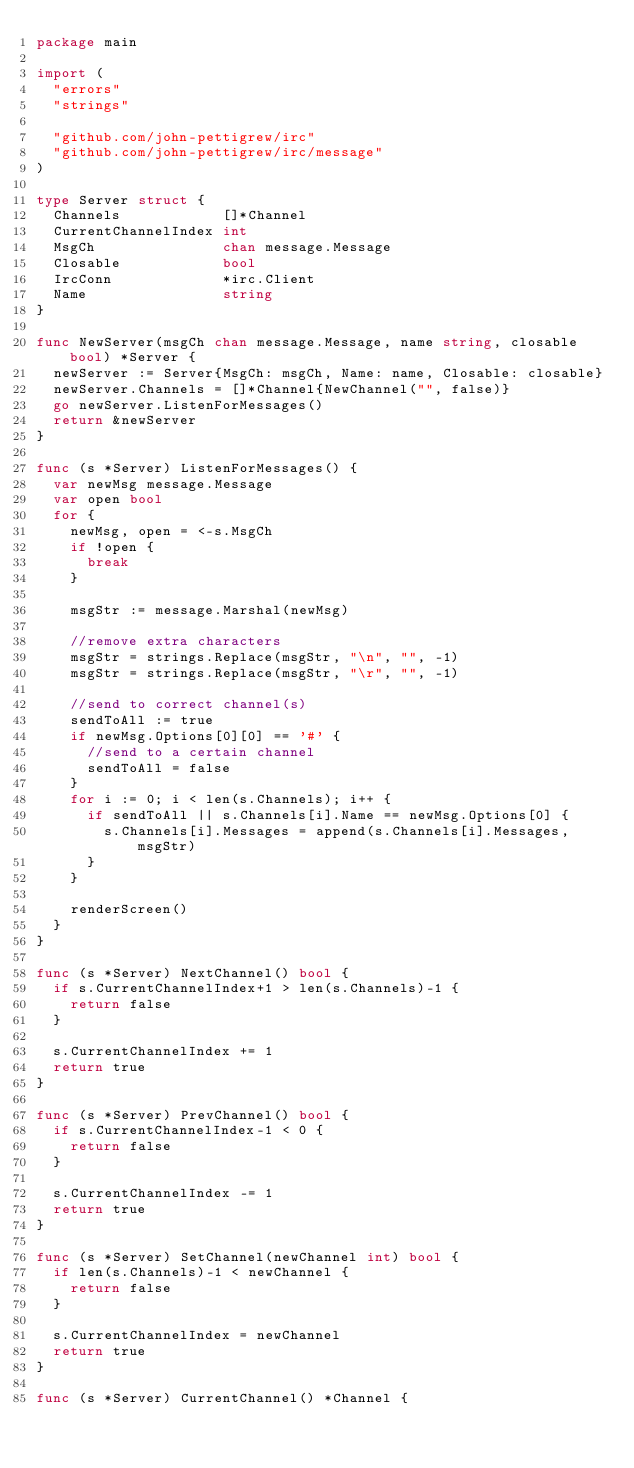<code> <loc_0><loc_0><loc_500><loc_500><_Go_>package main

import (
	"errors"
	"strings"

	"github.com/john-pettigrew/irc"
	"github.com/john-pettigrew/irc/message"
)

type Server struct {
	Channels            []*Channel
	CurrentChannelIndex int
	MsgCh               chan message.Message
	Closable            bool
	IrcConn             *irc.Client
	Name                string
}

func NewServer(msgCh chan message.Message, name string, closable bool) *Server {
	newServer := Server{MsgCh: msgCh, Name: name, Closable: closable}
	newServer.Channels = []*Channel{NewChannel("", false)}
	go newServer.ListenForMessages()
	return &newServer
}

func (s *Server) ListenForMessages() {
	var newMsg message.Message
	var open bool
	for {
		newMsg, open = <-s.MsgCh
		if !open {
			break
		}

		msgStr := message.Marshal(newMsg)

		//remove extra characters
		msgStr = strings.Replace(msgStr, "\n", "", -1)
		msgStr = strings.Replace(msgStr, "\r", "", -1)

		//send to correct channel(s)
		sendToAll := true
		if newMsg.Options[0][0] == '#' {
			//send to a certain channel
			sendToAll = false
		}
		for i := 0; i < len(s.Channels); i++ {
			if sendToAll || s.Channels[i].Name == newMsg.Options[0] {
				s.Channels[i].Messages = append(s.Channels[i].Messages, msgStr)
			}
		}

		renderScreen()
	}
}

func (s *Server) NextChannel() bool {
	if s.CurrentChannelIndex+1 > len(s.Channels)-1 {
		return false
	}

	s.CurrentChannelIndex += 1
	return true
}

func (s *Server) PrevChannel() bool {
	if s.CurrentChannelIndex-1 < 0 {
		return false
	}

	s.CurrentChannelIndex -= 1
	return true
}

func (s *Server) SetChannel(newChannel int) bool {
	if len(s.Channels)-1 < newChannel {
		return false
	}

	s.CurrentChannelIndex = newChannel
	return true
}

func (s *Server) CurrentChannel() *Channel {</code> 